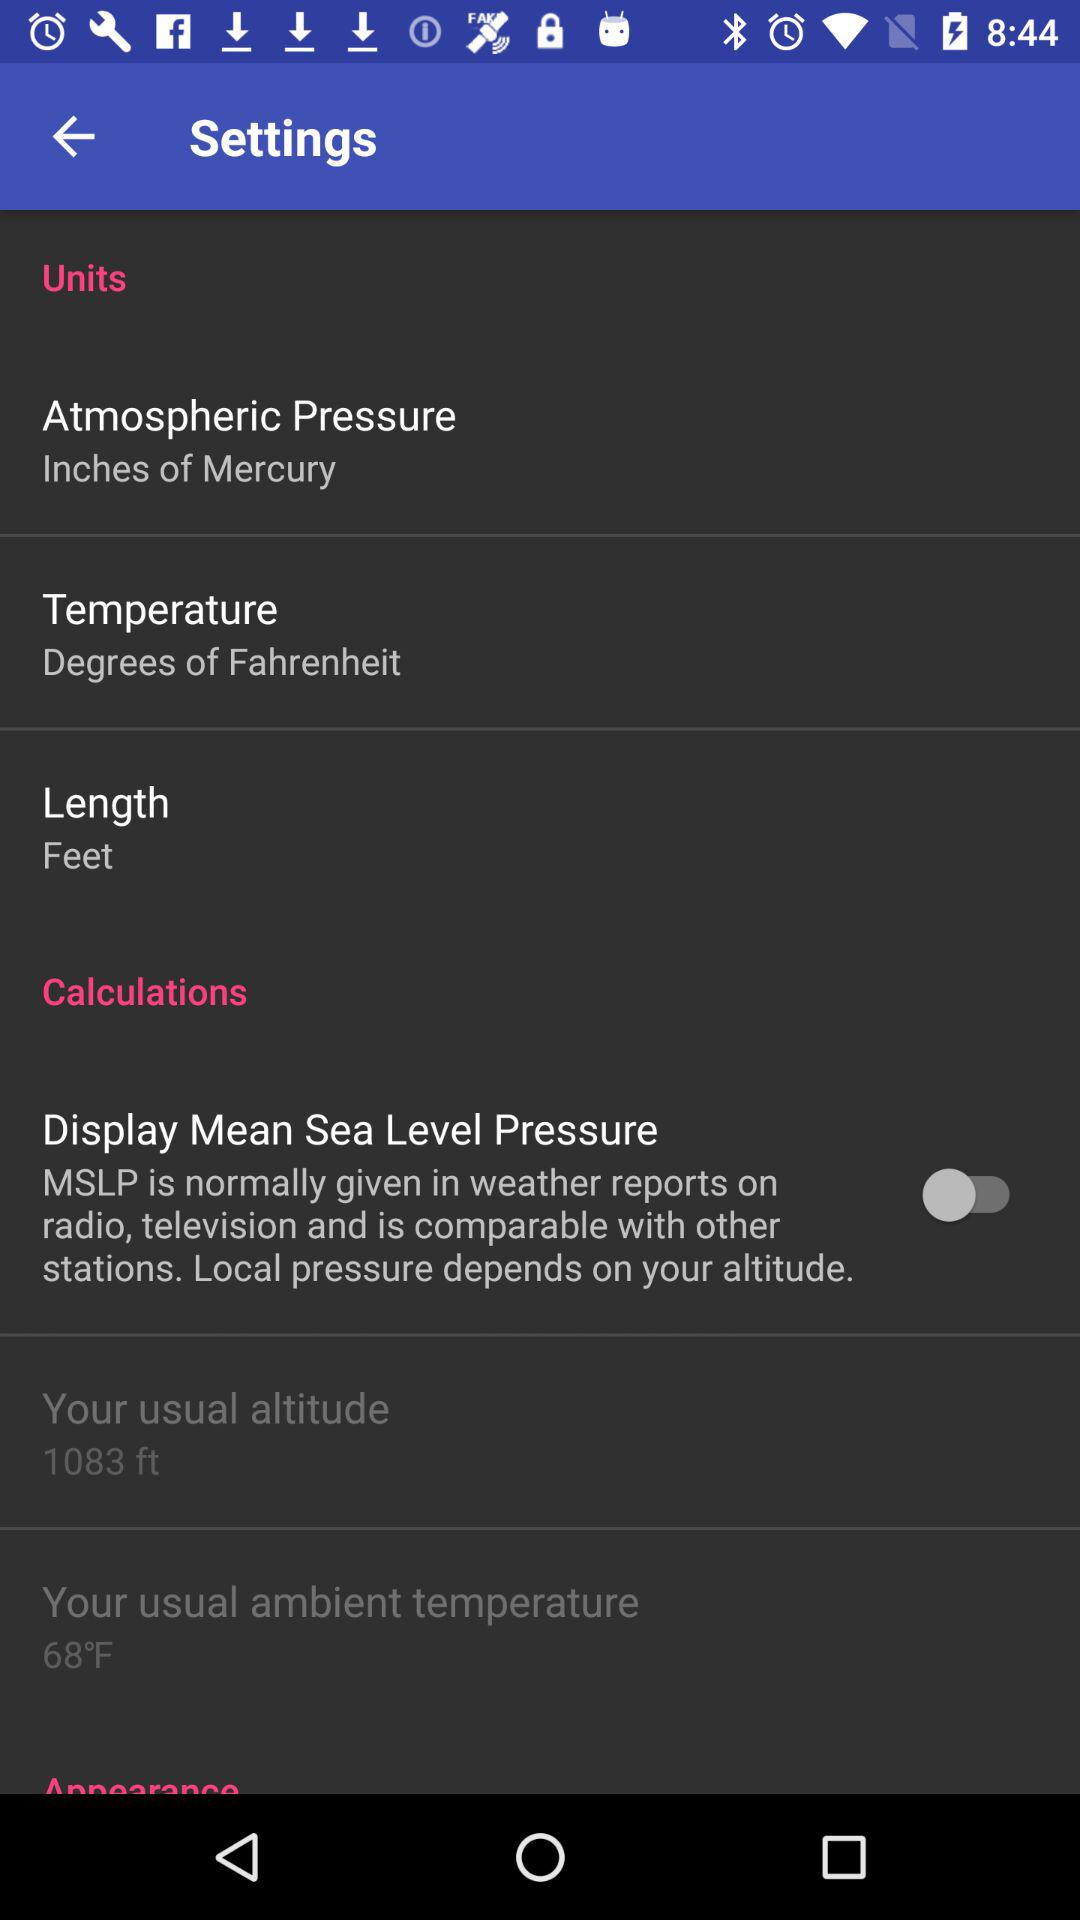What is the usual altitude? The usual altitude is 1083 ft. 